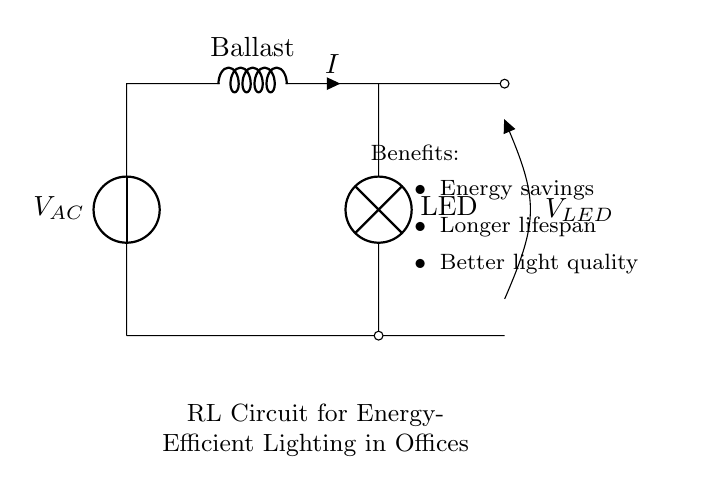What is the main energy-saving component in this circuit? The main energy-saving component is the inductor, functioning as a ballast which helps in managing the current flow and reducing energy wasted in heat.
Answer: inductor What type of lighting is used in this circuit? The circuit diagram shows an LED lamp, which is known for its energy efficiency compared to traditional lighting.
Answer: LED What does the symbol labeled "V AC" represent? The symbol labeled "V AC" represents the alternating current voltage source that supplies power to the circuit.
Answer: alternating current voltage source How does the inductor affect the efficiency of the lighting system? The inductor reduces the reactive power and stabilizes the current, which improves the overall efficiency of the lighting system by allowing more effective energy usage.
Answer: improves efficiency What is the benefit of using this RL circuit for office lighting? The main benefit is energy savings, as it allows for efficient operation of the lighting system, contributing to lower electricity costs.
Answer: energy savings What is connected in parallel to the LED? The open circuit labeled "V LED" indicates that a voltage measurement can be taken across the LED, showing how the LED is utilized but does not imply a connection in parallel.
Answer: voltage measurement (not parallel connected) What type of current is indicated by the flow direction through the inductor? The current indicated through the inductor is alternating current, which is shown by the alternating nature of the voltage source in the circuit.
Answer: alternating current 